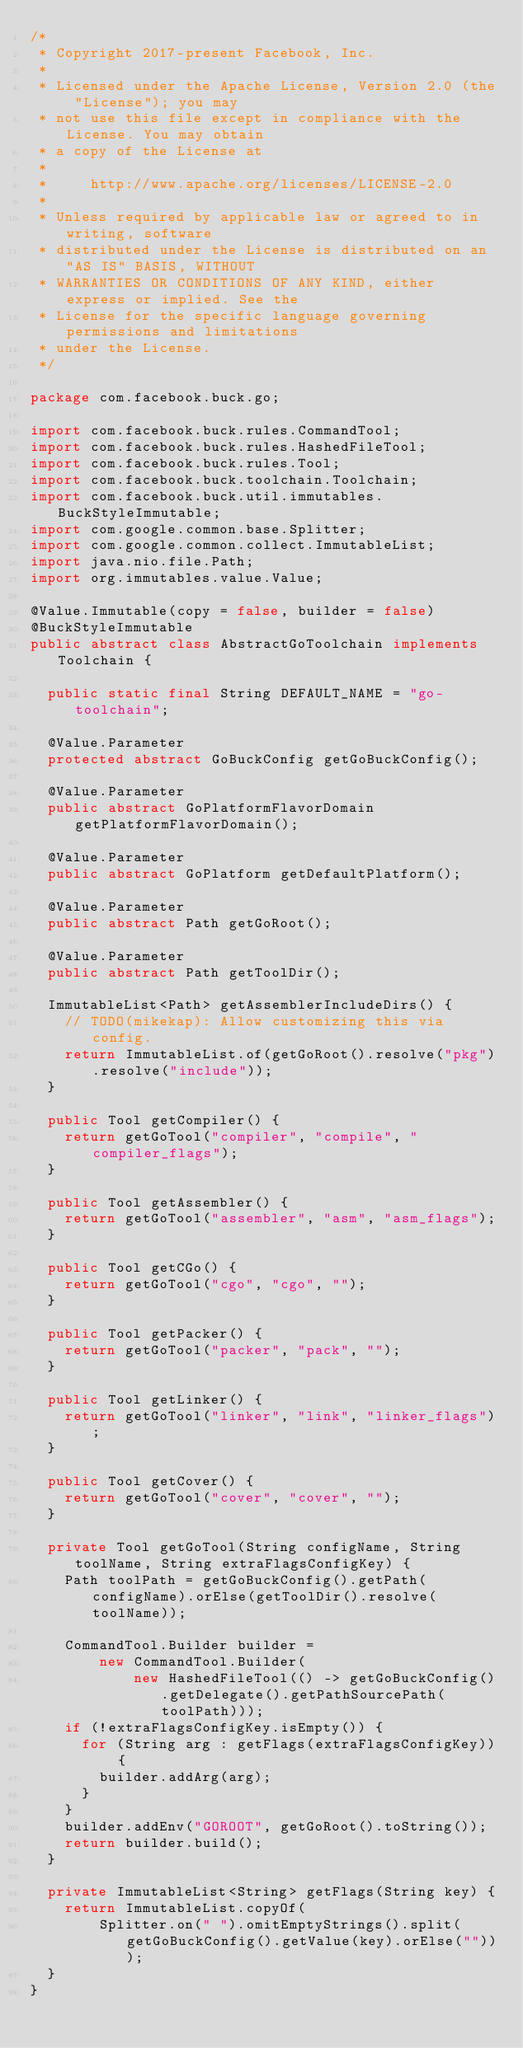Convert code to text. <code><loc_0><loc_0><loc_500><loc_500><_Java_>/*
 * Copyright 2017-present Facebook, Inc.
 *
 * Licensed under the Apache License, Version 2.0 (the "License"); you may
 * not use this file except in compliance with the License. You may obtain
 * a copy of the License at
 *
 *     http://www.apache.org/licenses/LICENSE-2.0
 *
 * Unless required by applicable law or agreed to in writing, software
 * distributed under the License is distributed on an "AS IS" BASIS, WITHOUT
 * WARRANTIES OR CONDITIONS OF ANY KIND, either express or implied. See the
 * License for the specific language governing permissions and limitations
 * under the License.
 */

package com.facebook.buck.go;

import com.facebook.buck.rules.CommandTool;
import com.facebook.buck.rules.HashedFileTool;
import com.facebook.buck.rules.Tool;
import com.facebook.buck.toolchain.Toolchain;
import com.facebook.buck.util.immutables.BuckStyleImmutable;
import com.google.common.base.Splitter;
import com.google.common.collect.ImmutableList;
import java.nio.file.Path;
import org.immutables.value.Value;

@Value.Immutable(copy = false, builder = false)
@BuckStyleImmutable
public abstract class AbstractGoToolchain implements Toolchain {

  public static final String DEFAULT_NAME = "go-toolchain";

  @Value.Parameter
  protected abstract GoBuckConfig getGoBuckConfig();

  @Value.Parameter
  public abstract GoPlatformFlavorDomain getPlatformFlavorDomain();

  @Value.Parameter
  public abstract GoPlatform getDefaultPlatform();

  @Value.Parameter
  public abstract Path getGoRoot();

  @Value.Parameter
  public abstract Path getToolDir();

  ImmutableList<Path> getAssemblerIncludeDirs() {
    // TODO(mikekap): Allow customizing this via config.
    return ImmutableList.of(getGoRoot().resolve("pkg").resolve("include"));
  }

  public Tool getCompiler() {
    return getGoTool("compiler", "compile", "compiler_flags");
  }

  public Tool getAssembler() {
    return getGoTool("assembler", "asm", "asm_flags");
  }

  public Tool getCGo() {
    return getGoTool("cgo", "cgo", "");
  }

  public Tool getPacker() {
    return getGoTool("packer", "pack", "");
  }

  public Tool getLinker() {
    return getGoTool("linker", "link", "linker_flags");
  }

  public Tool getCover() {
    return getGoTool("cover", "cover", "");
  }

  private Tool getGoTool(String configName, String toolName, String extraFlagsConfigKey) {
    Path toolPath = getGoBuckConfig().getPath(configName).orElse(getToolDir().resolve(toolName));

    CommandTool.Builder builder =
        new CommandTool.Builder(
            new HashedFileTool(() -> getGoBuckConfig().getDelegate().getPathSourcePath(toolPath)));
    if (!extraFlagsConfigKey.isEmpty()) {
      for (String arg : getFlags(extraFlagsConfigKey)) {
        builder.addArg(arg);
      }
    }
    builder.addEnv("GOROOT", getGoRoot().toString());
    return builder.build();
  }

  private ImmutableList<String> getFlags(String key) {
    return ImmutableList.copyOf(
        Splitter.on(" ").omitEmptyStrings().split(getGoBuckConfig().getValue(key).orElse("")));
  }
}
</code> 